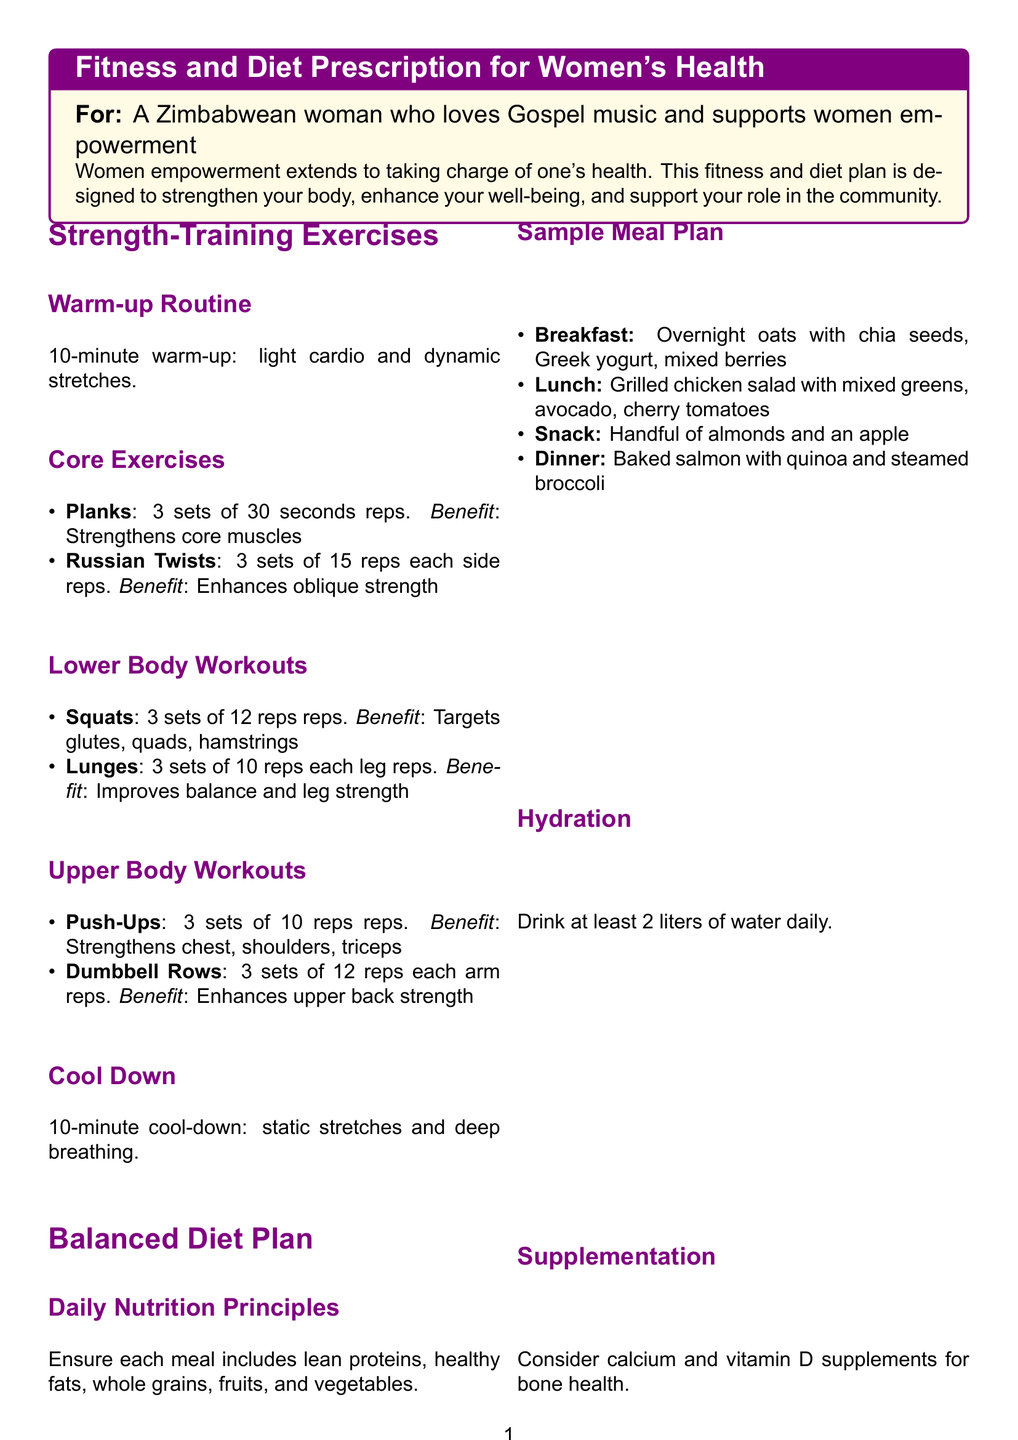What is the target number of sets for Planks? The document states that Planks require 3 sets of 30 seconds.
Answer: 3 sets How many liters of water should be consumed daily? The document states that the daily water intake should be at least 2 liters.
Answer: 2 liters What is included in the breakfast sample meal? The breakfast sample meal consists of overnight oats with chia seeds, Greek yogurt, and mixed berries.
Answer: Overnight oats with chia seeds, Greek yogurt, mixed berries What benefit does performing Squats provide? The document mentions that Squats target glutes, quads, and hamstrings.
Answer: Targets glutes, quads, hamstrings How long should the warm-up routine last? The document specifies that the warm-up routine is 10 minutes long.
Answer: 10 minutes What type of music should be included in the workout playlist? The document suggests including Gospel songs in the workout playlist.
Answer: Gospel songs How many reps are recommended for Russian Twists? The document indicates that Russian Twists require 3 sets of 15 reps each side.
Answer: 3 sets of 15 reps each side What healthy fat is included in the lunch sample meal? The lunch sample meal includes avocado as a healthy fat.
Answer: Avocado 